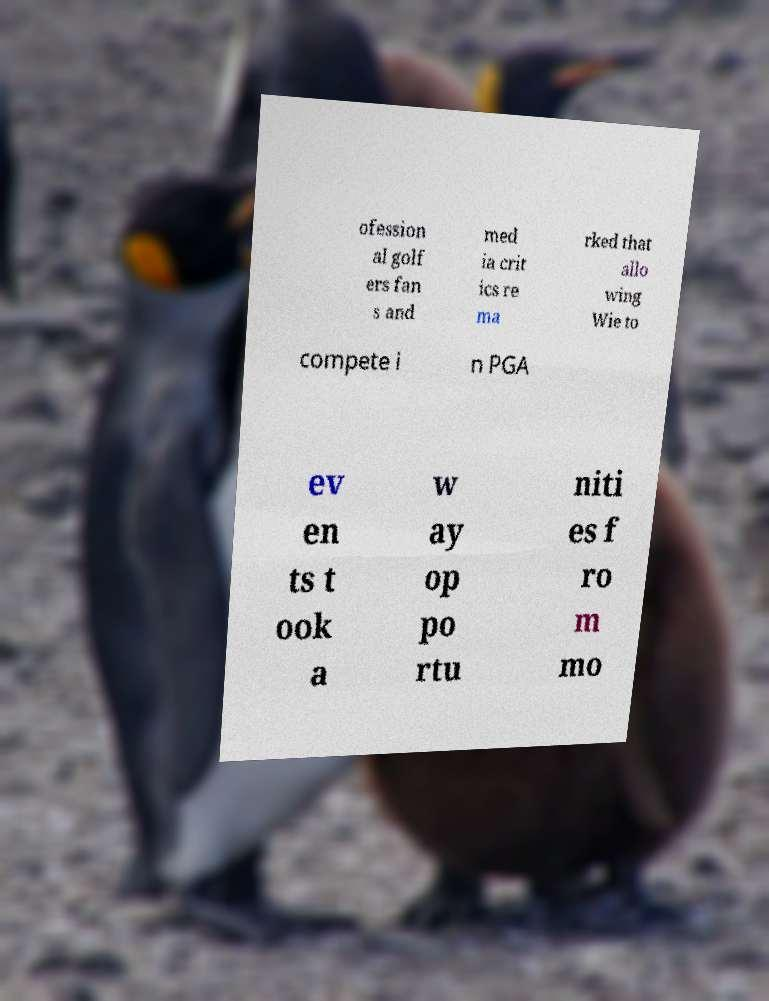Please read and relay the text visible in this image. What does it say? ofession al golf ers fan s and med ia crit ics re ma rked that allo wing Wie to compete i n PGA ev en ts t ook a w ay op po rtu niti es f ro m mo 